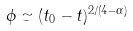Convert formula to latex. <formula><loc_0><loc_0><loc_500><loc_500>\phi \simeq ( t _ { 0 } - t ) ^ { 2 / ( 4 - \alpha ) }</formula> 